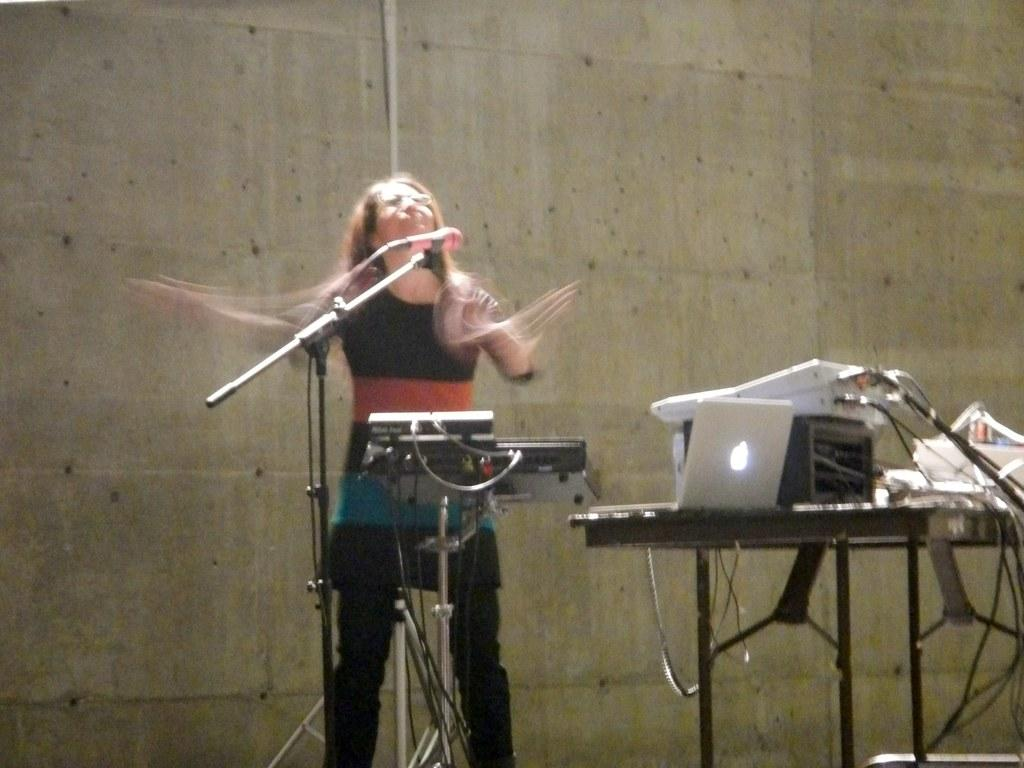Who is the main subject in the image? There is a woman in the image. What is the woman doing in the image? The woman is using a microphone and a laptop in the image. What is the woman sitting or standing near? There is a table in the image. What type of objects can be seen in the image? There are devices and other objects present in the image. What can be seen in the background of the image? There is a wall and a pipe in the background of the image. How does the woman react to the earthquake in the image? There is no earthquake present in the image. What type of tail can be seen on the woman in the image? There is no tail present on the woman in the image. 